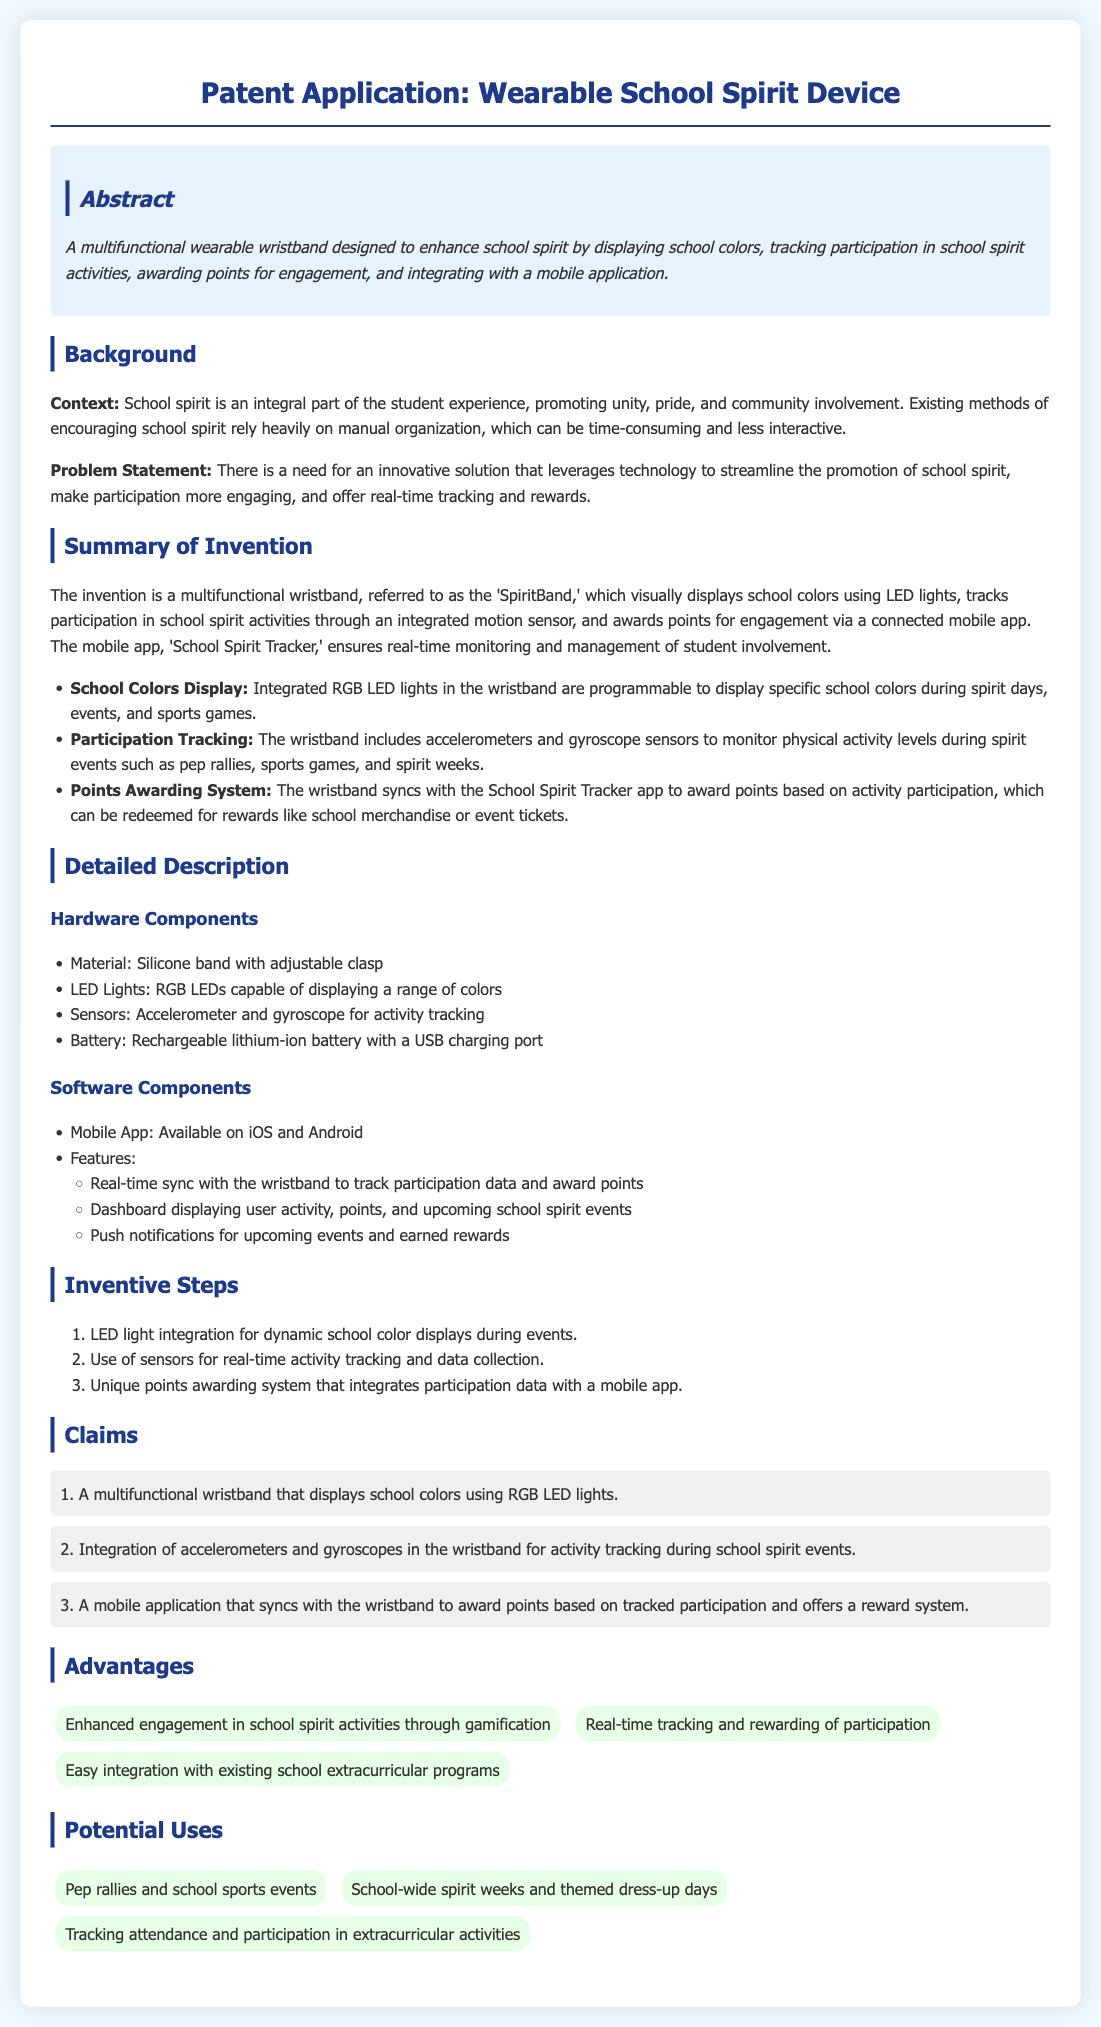What is the title of the patent application? The title is the main heading of the document, which describes the subject of the patent.
Answer: Wearable School Spirit Device What does the wristband visually display? This is mentioned in the summary of the invention as the primary function of the wristband.
Answer: School colors What type of sensors are included in the wristband? The sensors are listed under hardware components, indicating their role in tracking activities.
Answer: Accelerometer and gyroscope What is the name of the mobile app associated with the wristband? This is stated in the summary of the invention, under software components.
Answer: School Spirit Tracker What are the points awarded for? This is stated in the Summary of Invention and relates to how interaction with the device is rewarded.
Answer: Engagement How many claims are made in the document? The number of claims is indicated in the Claims section as distinct statements of what the invention is and does.
Answer: 3 What is one advantage of the wearable school spirit device? This can be found in the Advantages section providing specific benefits of the device.
Answer: Enhanced engagement in school spirit activities through gamification What is a potential use of the device? Potential uses are listed towards the end of the document, highlighting practical applications for the device.
Answer: Pep rallies and school sports events 